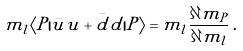<formula> <loc_0><loc_0><loc_500><loc_500>m _ { l } \langle P | \bar { u } u + \bar { d } d | P \rangle = m _ { l } \frac { \partial m _ { P } } { \partial m _ { l } } \, .</formula> 